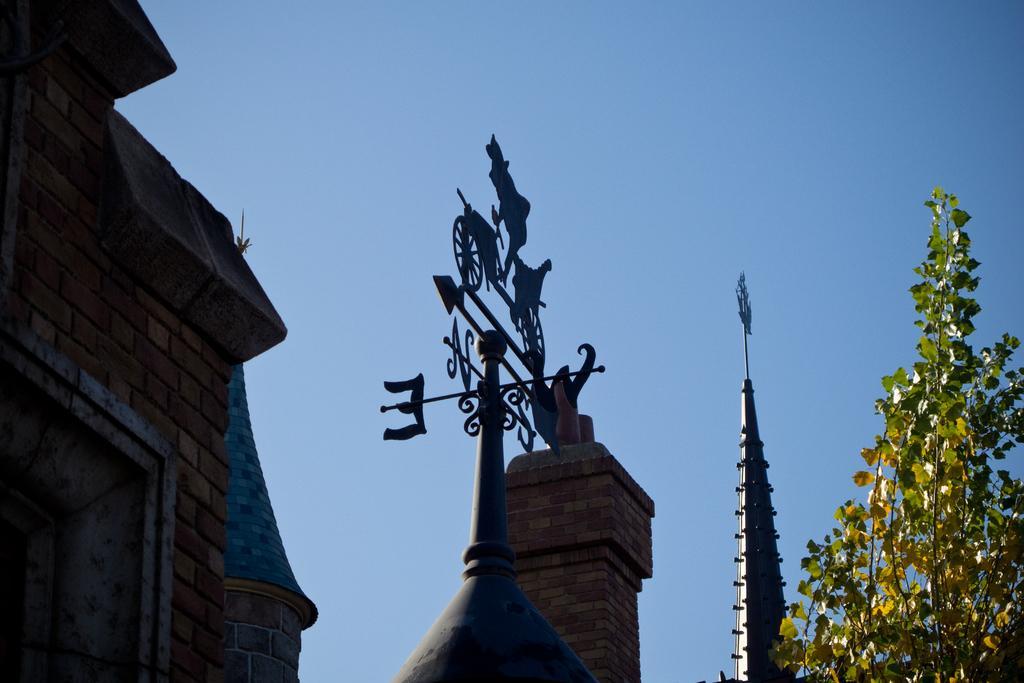Could you give a brief overview of what you see in this image? In this picture we can see a plant on the right side. There are some buildings visible in the background. We can see a brick wall on a building on the left side. Sky is blue in color. 